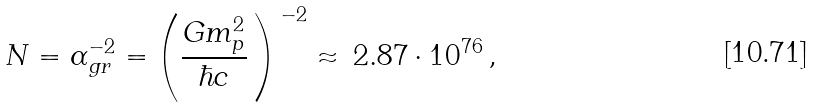Convert formula to latex. <formula><loc_0><loc_0><loc_500><loc_500>N = \alpha _ { g r } ^ { - 2 } = \left ( \frac { G m _ { p } ^ { 2 } } { \hbar { c } } \, \right ) ^ { \, - 2 } \approx \, 2 . 8 7 \cdot 1 0 ^ { 7 6 } \, ,</formula> 